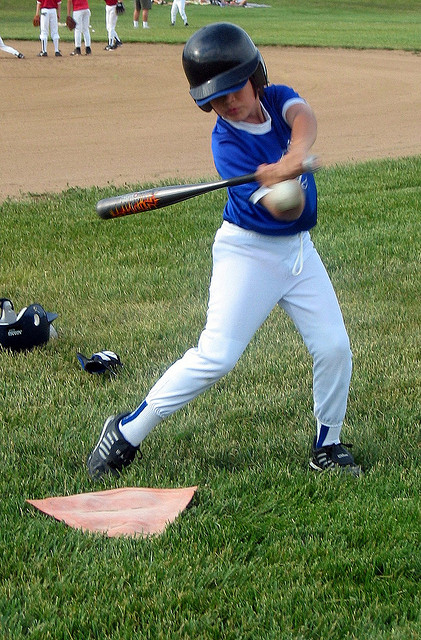<image>What is the bats brand? It is unclear what the brand of the bat is. It could be Rawlings, Wilson, Louisville Slugger, or something else. What is the bats brand? I don't know the brand of the bats. It could be Rawlings, Wilson, or Louisville Slugger. 